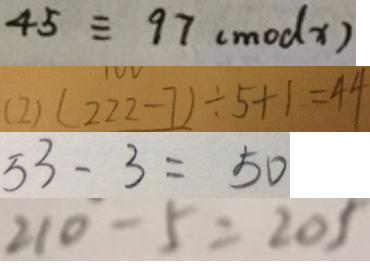Convert formula to latex. <formula><loc_0><loc_0><loc_500><loc_500>4 5 \equiv 9 7 ( m o d x ) 
 ( 2 ) ( 2 2 2 - 7 ) \div 5 + 1 = 4 4 
 5 3 - 3 = 5 0 
 2 1 0 - 5 = 2 0 5</formula> 